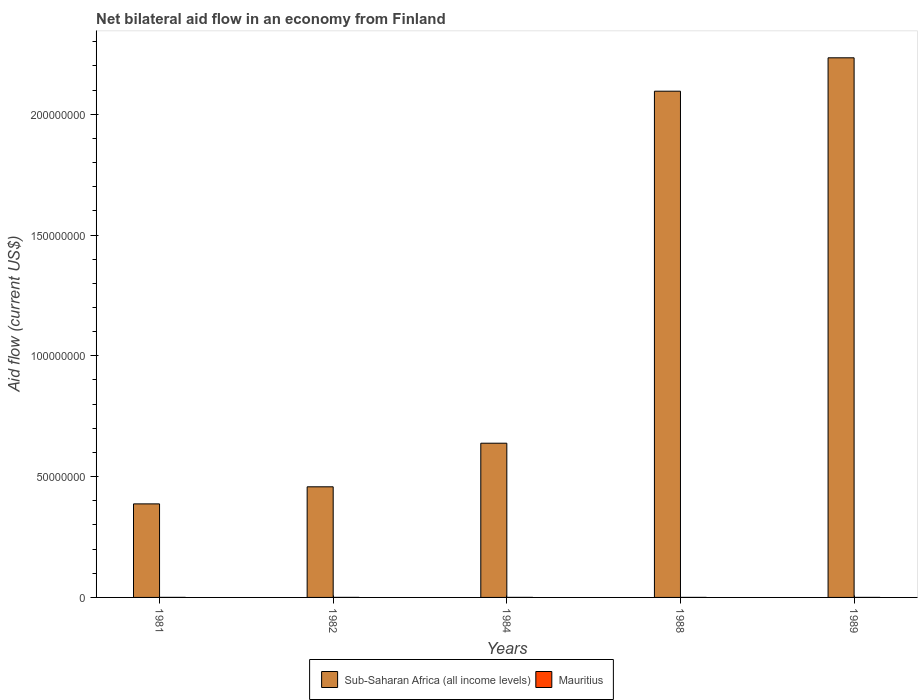How many groups of bars are there?
Your answer should be compact. 5. Are the number of bars per tick equal to the number of legend labels?
Your response must be concise. Yes. How many bars are there on the 3rd tick from the left?
Provide a short and direct response. 2. How many bars are there on the 2nd tick from the right?
Provide a short and direct response. 2. What is the label of the 3rd group of bars from the left?
Keep it short and to the point. 1984. Across all years, what is the maximum net bilateral aid flow in Sub-Saharan Africa (all income levels)?
Ensure brevity in your answer.  2.23e+08. Across all years, what is the minimum net bilateral aid flow in Mauritius?
Offer a very short reply. 10000. In which year was the net bilateral aid flow in Sub-Saharan Africa (all income levels) maximum?
Provide a short and direct response. 1989. In which year was the net bilateral aid flow in Mauritius minimum?
Offer a terse response. 1988. What is the difference between the net bilateral aid flow in Sub-Saharan Africa (all income levels) in 1982 and that in 1984?
Ensure brevity in your answer.  -1.80e+07. What is the difference between the net bilateral aid flow in Mauritius in 1988 and the net bilateral aid flow in Sub-Saharan Africa (all income levels) in 1984?
Keep it short and to the point. -6.38e+07. What is the average net bilateral aid flow in Mauritius per year?
Offer a very short reply. 1.60e+04. In the year 1984, what is the difference between the net bilateral aid flow in Sub-Saharan Africa (all income levels) and net bilateral aid flow in Mauritius?
Make the answer very short. 6.38e+07. In how many years, is the net bilateral aid flow in Sub-Saharan Africa (all income levels) greater than 210000000 US$?
Give a very brief answer. 1. What is the ratio of the net bilateral aid flow in Mauritius in 1982 to that in 1984?
Your response must be concise. 1. Is the net bilateral aid flow in Sub-Saharan Africa (all income levels) in 1984 less than that in 1988?
Your answer should be very brief. Yes. What is the difference between the highest and the second highest net bilateral aid flow in Mauritius?
Offer a very short reply. 0. What is the difference between the highest and the lowest net bilateral aid flow in Mauritius?
Your response must be concise. 10000. What does the 2nd bar from the left in 1984 represents?
Your answer should be compact. Mauritius. What does the 2nd bar from the right in 1989 represents?
Your answer should be very brief. Sub-Saharan Africa (all income levels). How many bars are there?
Your answer should be very brief. 10. Are all the bars in the graph horizontal?
Ensure brevity in your answer.  No. How many years are there in the graph?
Make the answer very short. 5. What is the difference between two consecutive major ticks on the Y-axis?
Provide a short and direct response. 5.00e+07. How are the legend labels stacked?
Your response must be concise. Horizontal. What is the title of the graph?
Keep it short and to the point. Net bilateral aid flow in an economy from Finland. What is the label or title of the X-axis?
Offer a terse response. Years. What is the label or title of the Y-axis?
Offer a very short reply. Aid flow (current US$). What is the Aid flow (current US$) in Sub-Saharan Africa (all income levels) in 1981?
Offer a very short reply. 3.87e+07. What is the Aid flow (current US$) of Sub-Saharan Africa (all income levels) in 1982?
Offer a very short reply. 4.58e+07. What is the Aid flow (current US$) in Sub-Saharan Africa (all income levels) in 1984?
Offer a terse response. 6.38e+07. What is the Aid flow (current US$) in Sub-Saharan Africa (all income levels) in 1988?
Offer a very short reply. 2.10e+08. What is the Aid flow (current US$) of Mauritius in 1988?
Provide a short and direct response. 10000. What is the Aid flow (current US$) of Sub-Saharan Africa (all income levels) in 1989?
Provide a succinct answer. 2.23e+08. What is the Aid flow (current US$) in Mauritius in 1989?
Give a very brief answer. 10000. Across all years, what is the maximum Aid flow (current US$) of Sub-Saharan Africa (all income levels)?
Give a very brief answer. 2.23e+08. Across all years, what is the maximum Aid flow (current US$) in Mauritius?
Offer a very short reply. 2.00e+04. Across all years, what is the minimum Aid flow (current US$) in Sub-Saharan Africa (all income levels)?
Keep it short and to the point. 3.87e+07. What is the total Aid flow (current US$) of Sub-Saharan Africa (all income levels) in the graph?
Ensure brevity in your answer.  5.81e+08. What is the total Aid flow (current US$) of Mauritius in the graph?
Your answer should be very brief. 8.00e+04. What is the difference between the Aid flow (current US$) of Sub-Saharan Africa (all income levels) in 1981 and that in 1982?
Make the answer very short. -7.07e+06. What is the difference between the Aid flow (current US$) in Sub-Saharan Africa (all income levels) in 1981 and that in 1984?
Your response must be concise. -2.51e+07. What is the difference between the Aid flow (current US$) in Mauritius in 1981 and that in 1984?
Offer a very short reply. 0. What is the difference between the Aid flow (current US$) of Sub-Saharan Africa (all income levels) in 1981 and that in 1988?
Your answer should be very brief. -1.71e+08. What is the difference between the Aid flow (current US$) in Sub-Saharan Africa (all income levels) in 1981 and that in 1989?
Your response must be concise. -1.85e+08. What is the difference between the Aid flow (current US$) in Sub-Saharan Africa (all income levels) in 1982 and that in 1984?
Give a very brief answer. -1.80e+07. What is the difference between the Aid flow (current US$) in Mauritius in 1982 and that in 1984?
Offer a terse response. 0. What is the difference between the Aid flow (current US$) of Sub-Saharan Africa (all income levels) in 1982 and that in 1988?
Make the answer very short. -1.64e+08. What is the difference between the Aid flow (current US$) in Sub-Saharan Africa (all income levels) in 1982 and that in 1989?
Give a very brief answer. -1.78e+08. What is the difference between the Aid flow (current US$) of Mauritius in 1982 and that in 1989?
Your answer should be very brief. 10000. What is the difference between the Aid flow (current US$) of Sub-Saharan Africa (all income levels) in 1984 and that in 1988?
Your response must be concise. -1.46e+08. What is the difference between the Aid flow (current US$) of Sub-Saharan Africa (all income levels) in 1984 and that in 1989?
Make the answer very short. -1.60e+08. What is the difference between the Aid flow (current US$) of Sub-Saharan Africa (all income levels) in 1988 and that in 1989?
Give a very brief answer. -1.38e+07. What is the difference between the Aid flow (current US$) of Mauritius in 1988 and that in 1989?
Ensure brevity in your answer.  0. What is the difference between the Aid flow (current US$) in Sub-Saharan Africa (all income levels) in 1981 and the Aid flow (current US$) in Mauritius in 1982?
Ensure brevity in your answer.  3.87e+07. What is the difference between the Aid flow (current US$) of Sub-Saharan Africa (all income levels) in 1981 and the Aid flow (current US$) of Mauritius in 1984?
Make the answer very short. 3.87e+07. What is the difference between the Aid flow (current US$) in Sub-Saharan Africa (all income levels) in 1981 and the Aid flow (current US$) in Mauritius in 1988?
Your answer should be very brief. 3.87e+07. What is the difference between the Aid flow (current US$) in Sub-Saharan Africa (all income levels) in 1981 and the Aid flow (current US$) in Mauritius in 1989?
Your answer should be very brief. 3.87e+07. What is the difference between the Aid flow (current US$) of Sub-Saharan Africa (all income levels) in 1982 and the Aid flow (current US$) of Mauritius in 1984?
Offer a terse response. 4.58e+07. What is the difference between the Aid flow (current US$) in Sub-Saharan Africa (all income levels) in 1982 and the Aid flow (current US$) in Mauritius in 1988?
Your response must be concise. 4.58e+07. What is the difference between the Aid flow (current US$) of Sub-Saharan Africa (all income levels) in 1982 and the Aid flow (current US$) of Mauritius in 1989?
Your answer should be very brief. 4.58e+07. What is the difference between the Aid flow (current US$) in Sub-Saharan Africa (all income levels) in 1984 and the Aid flow (current US$) in Mauritius in 1988?
Your answer should be very brief. 6.38e+07. What is the difference between the Aid flow (current US$) in Sub-Saharan Africa (all income levels) in 1984 and the Aid flow (current US$) in Mauritius in 1989?
Offer a terse response. 6.38e+07. What is the difference between the Aid flow (current US$) of Sub-Saharan Africa (all income levels) in 1988 and the Aid flow (current US$) of Mauritius in 1989?
Offer a terse response. 2.10e+08. What is the average Aid flow (current US$) in Sub-Saharan Africa (all income levels) per year?
Provide a succinct answer. 1.16e+08. What is the average Aid flow (current US$) in Mauritius per year?
Offer a terse response. 1.60e+04. In the year 1981, what is the difference between the Aid flow (current US$) in Sub-Saharan Africa (all income levels) and Aid flow (current US$) in Mauritius?
Keep it short and to the point. 3.87e+07. In the year 1982, what is the difference between the Aid flow (current US$) of Sub-Saharan Africa (all income levels) and Aid flow (current US$) of Mauritius?
Your answer should be very brief. 4.58e+07. In the year 1984, what is the difference between the Aid flow (current US$) of Sub-Saharan Africa (all income levels) and Aid flow (current US$) of Mauritius?
Keep it short and to the point. 6.38e+07. In the year 1988, what is the difference between the Aid flow (current US$) of Sub-Saharan Africa (all income levels) and Aid flow (current US$) of Mauritius?
Make the answer very short. 2.10e+08. In the year 1989, what is the difference between the Aid flow (current US$) in Sub-Saharan Africa (all income levels) and Aid flow (current US$) in Mauritius?
Give a very brief answer. 2.23e+08. What is the ratio of the Aid flow (current US$) in Sub-Saharan Africa (all income levels) in 1981 to that in 1982?
Provide a succinct answer. 0.85. What is the ratio of the Aid flow (current US$) of Mauritius in 1981 to that in 1982?
Keep it short and to the point. 1. What is the ratio of the Aid flow (current US$) of Sub-Saharan Africa (all income levels) in 1981 to that in 1984?
Your answer should be very brief. 0.61. What is the ratio of the Aid flow (current US$) of Sub-Saharan Africa (all income levels) in 1981 to that in 1988?
Offer a very short reply. 0.18. What is the ratio of the Aid flow (current US$) of Mauritius in 1981 to that in 1988?
Offer a terse response. 2. What is the ratio of the Aid flow (current US$) of Sub-Saharan Africa (all income levels) in 1981 to that in 1989?
Make the answer very short. 0.17. What is the ratio of the Aid flow (current US$) of Mauritius in 1981 to that in 1989?
Offer a very short reply. 2. What is the ratio of the Aid flow (current US$) of Sub-Saharan Africa (all income levels) in 1982 to that in 1984?
Your response must be concise. 0.72. What is the ratio of the Aid flow (current US$) in Mauritius in 1982 to that in 1984?
Ensure brevity in your answer.  1. What is the ratio of the Aid flow (current US$) in Sub-Saharan Africa (all income levels) in 1982 to that in 1988?
Offer a very short reply. 0.22. What is the ratio of the Aid flow (current US$) of Mauritius in 1982 to that in 1988?
Keep it short and to the point. 2. What is the ratio of the Aid flow (current US$) in Sub-Saharan Africa (all income levels) in 1982 to that in 1989?
Your answer should be very brief. 0.2. What is the ratio of the Aid flow (current US$) of Mauritius in 1982 to that in 1989?
Your response must be concise. 2. What is the ratio of the Aid flow (current US$) in Sub-Saharan Africa (all income levels) in 1984 to that in 1988?
Your answer should be very brief. 0.3. What is the ratio of the Aid flow (current US$) in Sub-Saharan Africa (all income levels) in 1984 to that in 1989?
Give a very brief answer. 0.29. What is the ratio of the Aid flow (current US$) in Sub-Saharan Africa (all income levels) in 1988 to that in 1989?
Offer a terse response. 0.94. What is the difference between the highest and the second highest Aid flow (current US$) in Sub-Saharan Africa (all income levels)?
Make the answer very short. 1.38e+07. What is the difference between the highest and the lowest Aid flow (current US$) of Sub-Saharan Africa (all income levels)?
Offer a very short reply. 1.85e+08. 